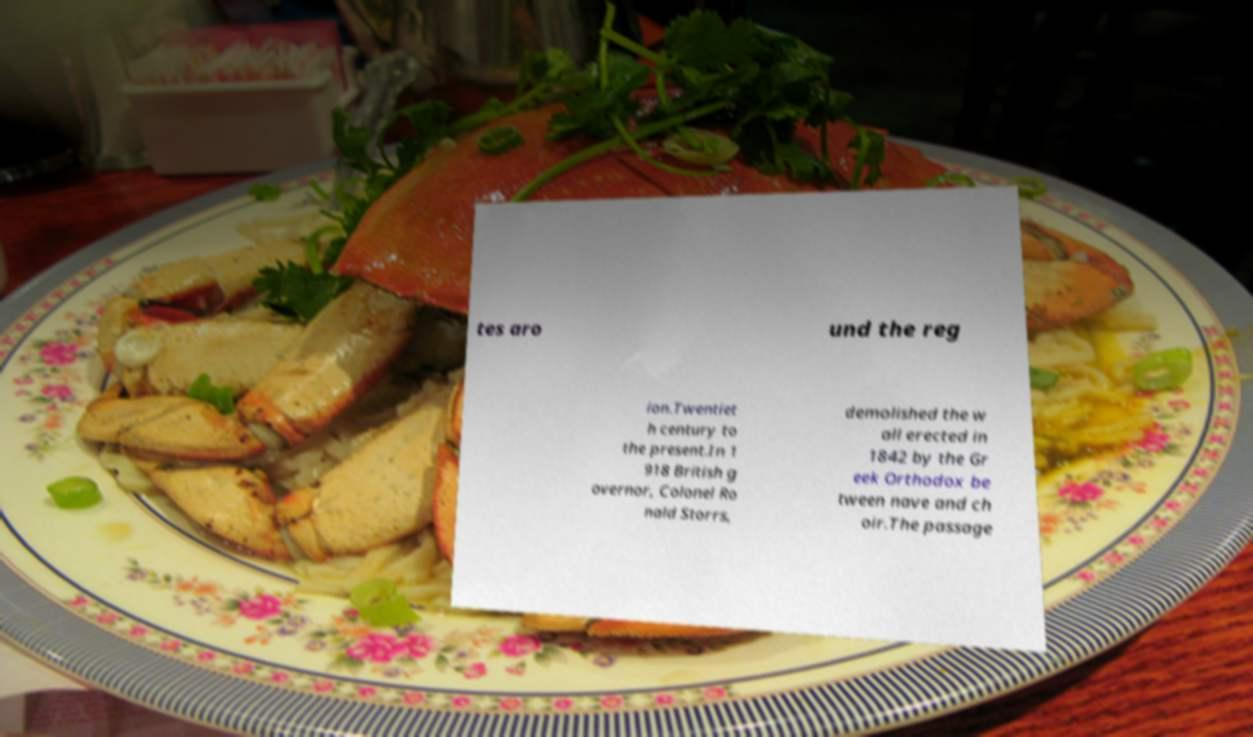I need the written content from this picture converted into text. Can you do that? tes aro und the reg ion.Twentiet h century to the present.In 1 918 British g overnor, Colonel Ro nald Storrs, demolished the w all erected in 1842 by the Gr eek Orthodox be tween nave and ch oir.The passage 